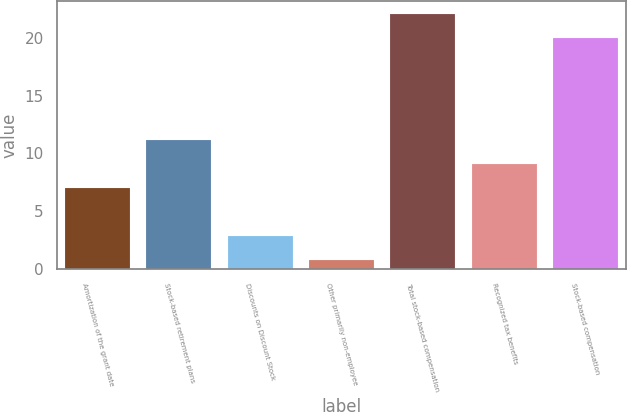Convert chart to OTSL. <chart><loc_0><loc_0><loc_500><loc_500><bar_chart><fcel>Amortization of the grant date<fcel>Stock-based retirement plans<fcel>Discounts on Discount Stock<fcel>Other primarily non-employee<fcel>Total stock-based compensation<fcel>Recognized tax benefits<fcel>Stock-based compensation<nl><fcel>7<fcel>11.16<fcel>2.88<fcel>0.8<fcel>22.08<fcel>9.08<fcel>20<nl></chart> 